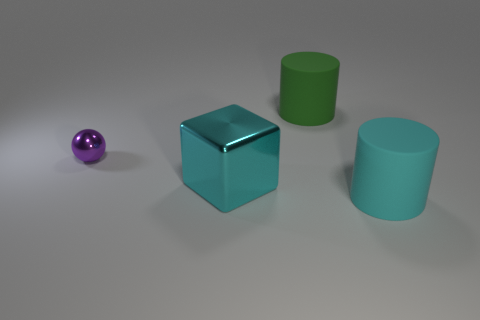Are there an equal number of large cyan metallic blocks that are behind the purple ball and large green cylinders?
Offer a very short reply. No. The tiny shiny object is what shape?
Give a very brief answer. Sphere. Is there any other thing that is the same color as the large cube?
Provide a succinct answer. Yes. There is a object that is left of the cyan cube; is it the same size as the rubber thing that is in front of the big shiny cube?
Your answer should be compact. No. There is a large matte thing that is behind the big matte thing in front of the purple shiny object; what is its shape?
Give a very brief answer. Cylinder. There is a cyan rubber cylinder; is it the same size as the rubber thing behind the large cyan rubber thing?
Provide a short and direct response. Yes. How big is the thing behind the thing left of the large cyan object left of the cyan matte thing?
Give a very brief answer. Large. How many things are things that are to the right of the big cube or small spheres?
Make the answer very short. 3. How many big cyan things are to the left of the matte object that is in front of the small purple sphere?
Provide a short and direct response. 1. Are there more metallic cubes that are left of the large cube than large yellow objects?
Your answer should be very brief. No. 